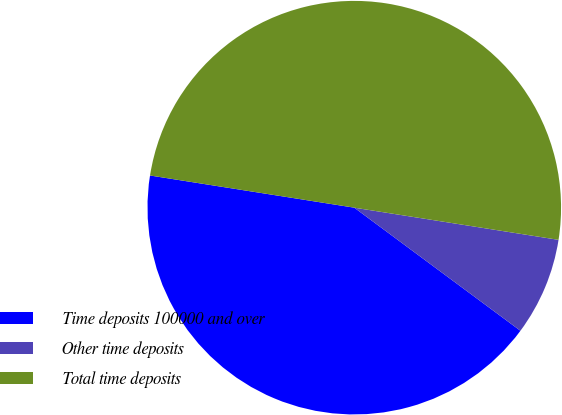Convert chart to OTSL. <chart><loc_0><loc_0><loc_500><loc_500><pie_chart><fcel>Time deposits 100000 and over<fcel>Other time deposits<fcel>Total time deposits<nl><fcel>42.34%<fcel>7.66%<fcel>50.0%<nl></chart> 